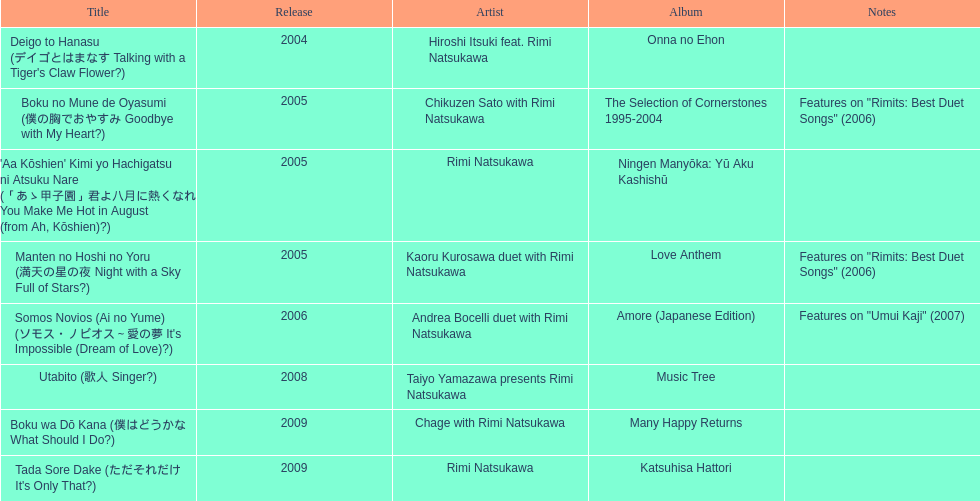In which year were the most titles launched? 2005. 